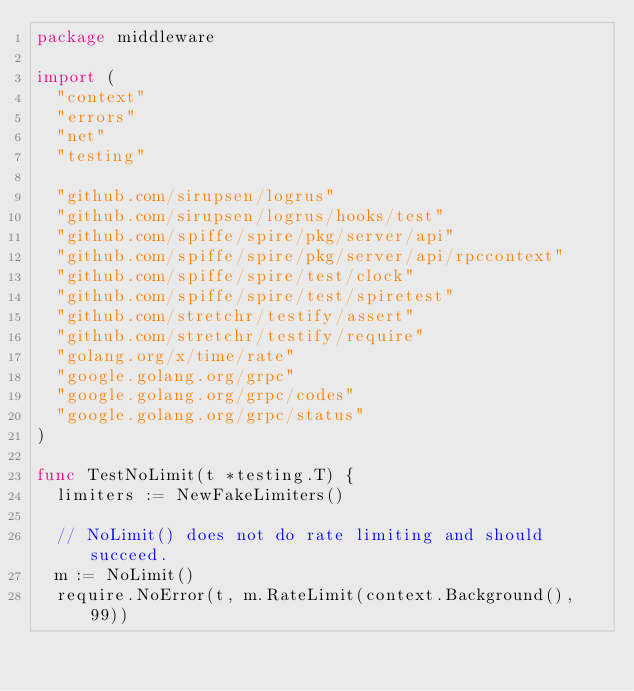<code> <loc_0><loc_0><loc_500><loc_500><_Go_>package middleware

import (
	"context"
	"errors"
	"net"
	"testing"

	"github.com/sirupsen/logrus"
	"github.com/sirupsen/logrus/hooks/test"
	"github.com/spiffe/spire/pkg/server/api"
	"github.com/spiffe/spire/pkg/server/api/rpccontext"
	"github.com/spiffe/spire/test/clock"
	"github.com/spiffe/spire/test/spiretest"
	"github.com/stretchr/testify/assert"
	"github.com/stretchr/testify/require"
	"golang.org/x/time/rate"
	"google.golang.org/grpc"
	"google.golang.org/grpc/codes"
	"google.golang.org/grpc/status"
)

func TestNoLimit(t *testing.T) {
	limiters := NewFakeLimiters()

	// NoLimit() does not do rate limiting and should succeed.
	m := NoLimit()
	require.NoError(t, m.RateLimit(context.Background(), 99))
</code> 